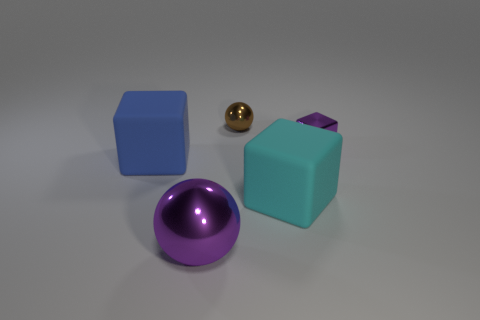What can you infer about the material of these objects? The objects appear to have different materials. The spheres have a reflective, shiny surface which could indicate they are made of polished metal or glass. The cubes, while also shiny, have a more matte appearance which might suggest a solid material like plastic. Do you think the light source has an effect on how we perceive their material? Absolutely, the light source plays a crucial role. It enhances the shiny surfaces of the spheres, making them look lustrous and reflective. For the cubes, the light creates soft shadows and subtle highlights, giving a clear sense of their solidity and matte texture. 